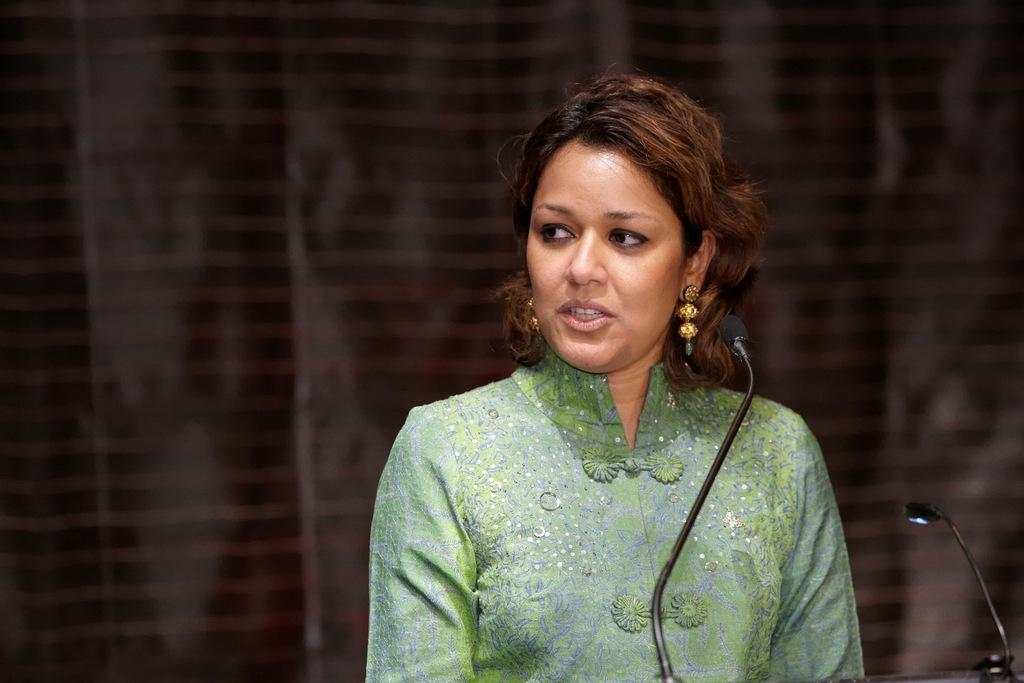Who is the main subject in the image? There is a woman in the image. What is the woman wearing? The woman is wearing a green dress. What object is in front of the woman? There is a microphone in front of the woman. What color is the curtain in the background of the image? There is a brown-colored curtain in the background of the image. What type of vest is the woman wearing in the image? The woman is not wearing a vest in the image; she is wearing a green dress. What type of beef is being served in the image? There is no beef present in the image. 